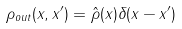Convert formula to latex. <formula><loc_0><loc_0><loc_500><loc_500>\rho _ { o u t } ( x , x ^ { \prime } ) = { \hat { \rho } } ( x ) \delta ( x - x ^ { \prime } )</formula> 